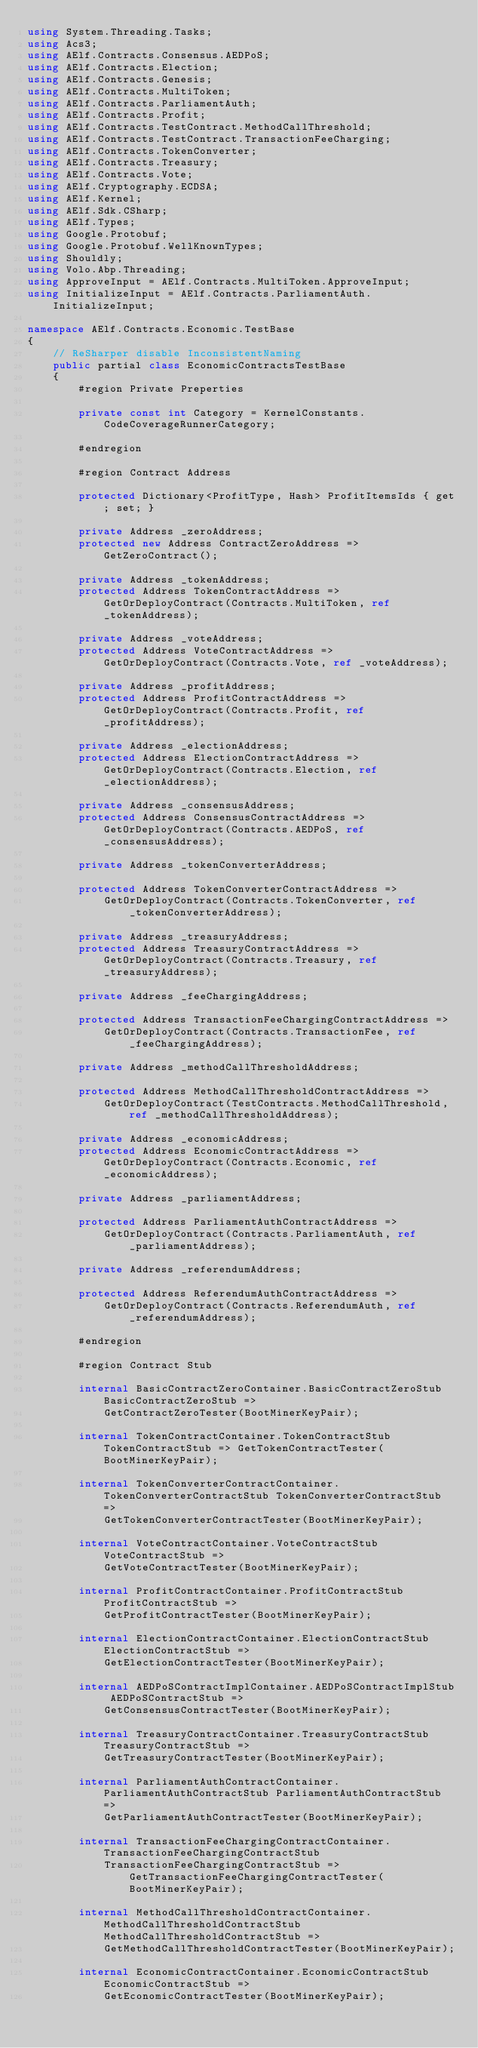<code> <loc_0><loc_0><loc_500><loc_500><_C#_>using System.Threading.Tasks;
using Acs3;
using AElf.Contracts.Consensus.AEDPoS;
using AElf.Contracts.Election;
using AElf.Contracts.Genesis;
using AElf.Contracts.MultiToken;
using AElf.Contracts.ParliamentAuth;
using AElf.Contracts.Profit;
using AElf.Contracts.TestContract.MethodCallThreshold;
using AElf.Contracts.TestContract.TransactionFeeCharging;
using AElf.Contracts.TokenConverter;
using AElf.Contracts.Treasury;
using AElf.Contracts.Vote;
using AElf.Cryptography.ECDSA;
using AElf.Kernel;
using AElf.Sdk.CSharp;
using AElf.Types;
using Google.Protobuf;
using Google.Protobuf.WellKnownTypes;
using Shouldly;
using Volo.Abp.Threading;
using ApproveInput = AElf.Contracts.MultiToken.ApproveInput;
using InitializeInput = AElf.Contracts.ParliamentAuth.InitializeInput;

namespace AElf.Contracts.Economic.TestBase
{
    // ReSharper disable InconsistentNaming
    public partial class EconomicContractsTestBase
    {
        #region Private Preperties

        private const int Category = KernelConstants.CodeCoverageRunnerCategory;

        #endregion

        #region Contract Address

        protected Dictionary<ProfitType, Hash> ProfitItemsIds { get; set; }

        private Address _zeroAddress;
        protected new Address ContractZeroAddress => GetZeroContract();

        private Address _tokenAddress;
        protected Address TokenContractAddress => GetOrDeployContract(Contracts.MultiToken, ref _tokenAddress);

        private Address _voteAddress;
        protected Address VoteContractAddress => GetOrDeployContract(Contracts.Vote, ref _voteAddress);

        private Address _profitAddress;
        protected Address ProfitContractAddress => GetOrDeployContract(Contracts.Profit, ref _profitAddress);

        private Address _electionAddress;
        protected Address ElectionContractAddress => GetOrDeployContract(Contracts.Election, ref _electionAddress);

        private Address _consensusAddress;
        protected Address ConsensusContractAddress => GetOrDeployContract(Contracts.AEDPoS, ref _consensusAddress);

        private Address _tokenConverterAddress;

        protected Address TokenConverterContractAddress =>
            GetOrDeployContract(Contracts.TokenConverter, ref _tokenConverterAddress);

        private Address _treasuryAddress;
        protected Address TreasuryContractAddress => GetOrDeployContract(Contracts.Treasury, ref _treasuryAddress);

        private Address _feeChargingAddress;

        protected Address TransactionFeeChargingContractAddress =>
            GetOrDeployContract(Contracts.TransactionFee, ref _feeChargingAddress);

        private Address _methodCallThresholdAddress;

        protected Address MethodCallThresholdContractAddress =>
            GetOrDeployContract(TestContracts.MethodCallThreshold, ref _methodCallThresholdAddress);

        private Address _economicAddress;
        protected Address EconomicContractAddress => GetOrDeployContract(Contracts.Economic, ref _economicAddress);

        private Address _parliamentAddress;

        protected Address ParliamentAuthContractAddress =>
            GetOrDeployContract(Contracts.ParliamentAuth, ref _parliamentAddress);
        
        private Address _referendumAddress;

        protected Address ReferendumAuthContractAddress =>
            GetOrDeployContract(Contracts.ReferendumAuth, ref _referendumAddress);

        #endregion

        #region Contract Stub

        internal BasicContractZeroContainer.BasicContractZeroStub BasicContractZeroStub =>
            GetContractZeroTester(BootMinerKeyPair);

        internal TokenContractContainer.TokenContractStub TokenContractStub => GetTokenContractTester(BootMinerKeyPair);

        internal TokenConverterContractContainer.TokenConverterContractStub TokenConverterContractStub =>
            GetTokenConverterContractTester(BootMinerKeyPair);

        internal VoteContractContainer.VoteContractStub VoteContractStub =>
            GetVoteContractTester(BootMinerKeyPair);

        internal ProfitContractContainer.ProfitContractStub ProfitContractStub =>
            GetProfitContractTester(BootMinerKeyPair);

        internal ElectionContractContainer.ElectionContractStub ElectionContractStub =>
            GetElectionContractTester(BootMinerKeyPair);

        internal AEDPoSContractImplContainer.AEDPoSContractImplStub AEDPoSContractStub =>
            GetConsensusContractTester(BootMinerKeyPair);

        internal TreasuryContractContainer.TreasuryContractStub TreasuryContractStub =>
            GetTreasuryContractTester(BootMinerKeyPair);

        internal ParliamentAuthContractContainer.ParliamentAuthContractStub ParliamentAuthContractStub =>
            GetParliamentAuthContractTester(BootMinerKeyPair);

        internal TransactionFeeChargingContractContainer.TransactionFeeChargingContractStub
            TransactionFeeChargingContractStub => GetTransactionFeeChargingContractTester(BootMinerKeyPair);

        internal MethodCallThresholdContractContainer.MethodCallThresholdContractStub MethodCallThresholdContractStub =>
            GetMethodCallThresholdContractTester(BootMinerKeyPair);

        internal EconomicContractContainer.EconomicContractStub EconomicContractStub =>
            GetEconomicContractTester(BootMinerKeyPair);
</code> 